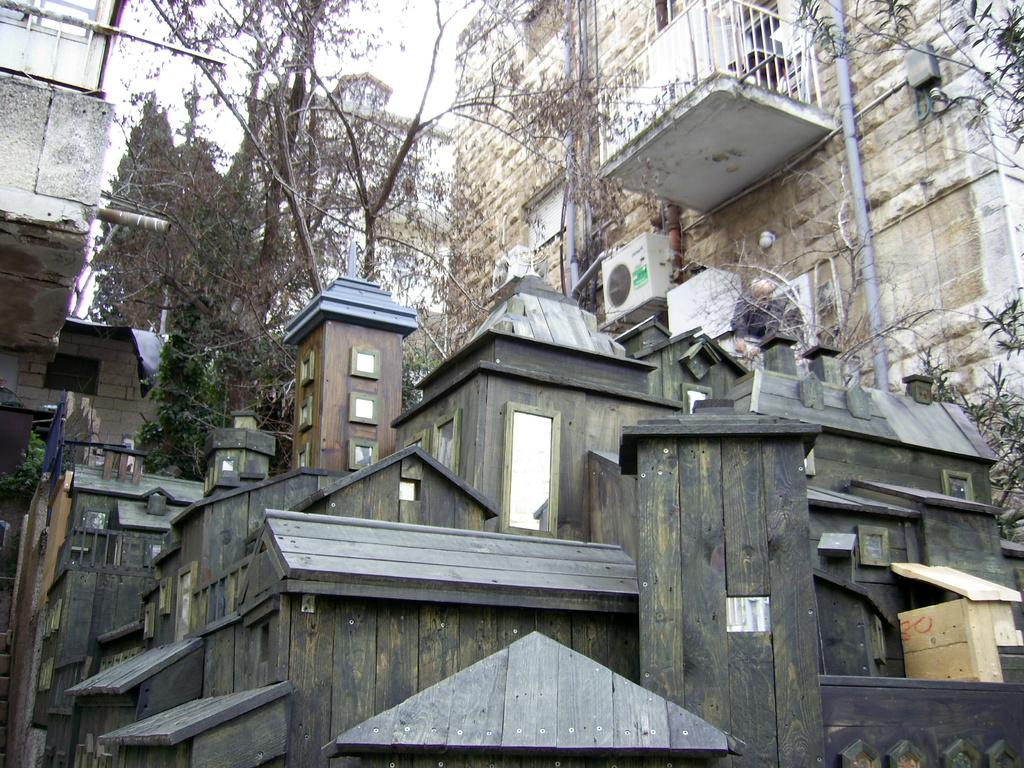What type of house is in the center of the image? There is a wooden house in the center of the image. What can be seen in the background of the image? There are buildings and trees in the background of the image. What type of flesh can be seen hanging from the trees in the image? There is no flesh present in the image; it features a wooden house and trees in the background. 